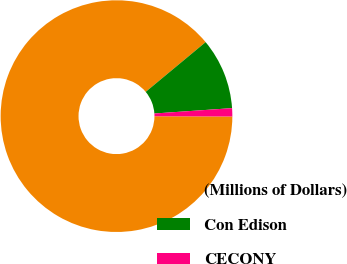<chart> <loc_0><loc_0><loc_500><loc_500><pie_chart><fcel>(Millions of Dollars)<fcel>Con Edison<fcel>CECONY<nl><fcel>88.93%<fcel>9.93%<fcel>1.15%<nl></chart> 